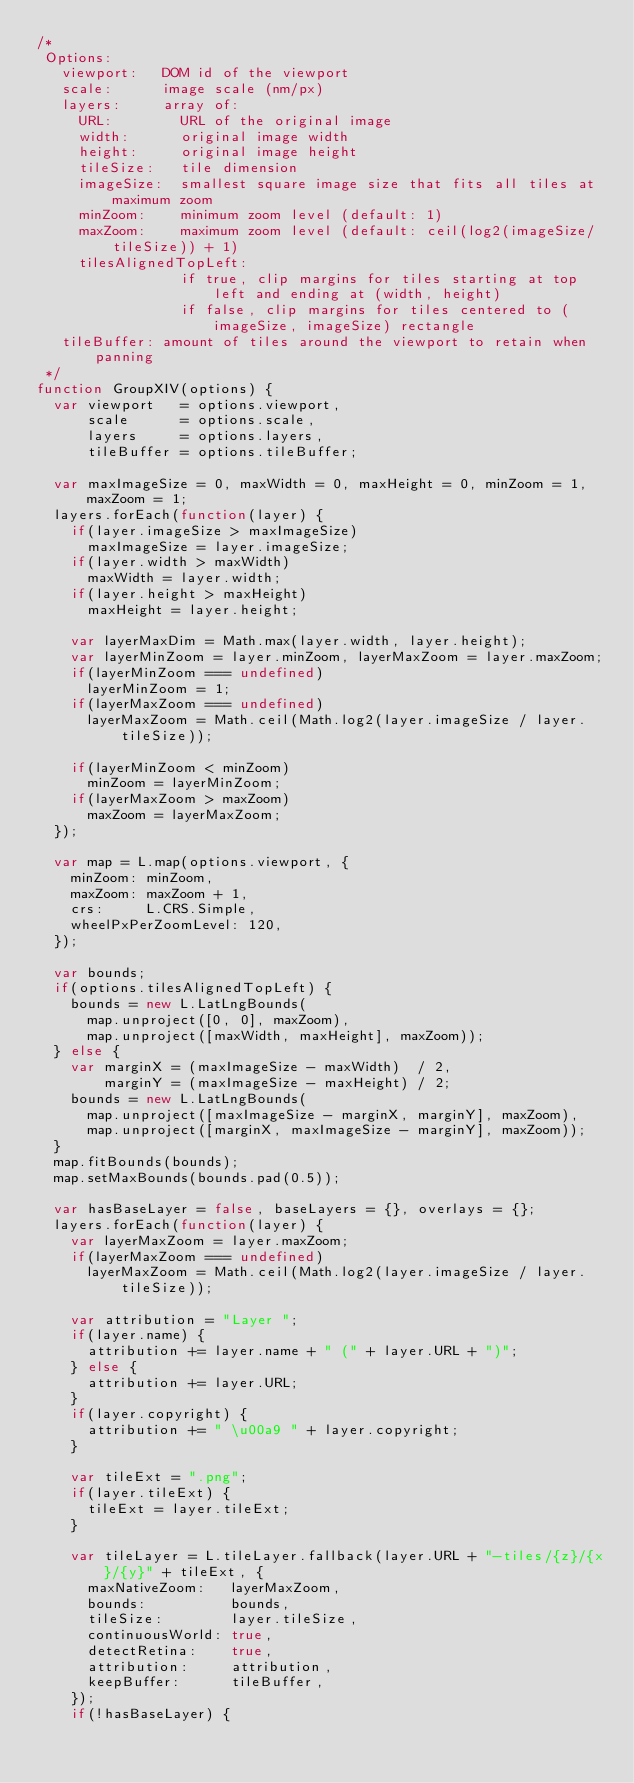Convert code to text. <code><loc_0><loc_0><loc_500><loc_500><_JavaScript_>/*
 Options:
   viewport:   DOM id of the viewport
   scale:      image scale (nm/px)
   layers:     array of:
     URL:        URL of the original image
     width:      original image width
     height:     original image height
     tileSize:   tile dimension
     imageSize:  smallest square image size that fits all tiles at maximum zoom
     minZoom:    minimum zoom level (default: 1)
     maxZoom:    maximum zoom level (default: ceil(log2(imageSize/tileSize)) + 1)
     tilesAlignedTopLeft:
                 if true, clip margins for tiles starting at top left and ending at (width, height)
                 if false, clip margins for tiles centered to (imageSize, imageSize) rectangle
   tileBuffer: amount of tiles around the viewport to retain when panning
 */
function GroupXIV(options) {
  var viewport   = options.viewport,
      scale      = options.scale,
      layers     = options.layers,
      tileBuffer = options.tileBuffer;

  var maxImageSize = 0, maxWidth = 0, maxHeight = 0, minZoom = 1, maxZoom = 1;
  layers.forEach(function(layer) {
    if(layer.imageSize > maxImageSize)
      maxImageSize = layer.imageSize;
    if(layer.width > maxWidth)
      maxWidth = layer.width;
    if(layer.height > maxHeight)
      maxHeight = layer.height;

    var layerMaxDim = Math.max(layer.width, layer.height);
    var layerMinZoom = layer.minZoom, layerMaxZoom = layer.maxZoom;
    if(layerMinZoom === undefined)
      layerMinZoom = 1;
    if(layerMaxZoom === undefined)
      layerMaxZoom = Math.ceil(Math.log2(layer.imageSize / layer.tileSize));

    if(layerMinZoom < minZoom)
      minZoom = layerMinZoom;
    if(layerMaxZoom > maxZoom)
      maxZoom = layerMaxZoom;
  });

  var map = L.map(options.viewport, {
    minZoom: minZoom,
    maxZoom: maxZoom + 1,
    crs:     L.CRS.Simple,
    wheelPxPerZoomLevel: 120,
  });

  var bounds;
  if(options.tilesAlignedTopLeft) {
    bounds = new L.LatLngBounds(
      map.unproject([0, 0], maxZoom),
      map.unproject([maxWidth, maxHeight], maxZoom));
  } else {
    var marginX = (maxImageSize - maxWidth)  / 2,
        marginY = (maxImageSize - maxHeight) / 2;
    bounds = new L.LatLngBounds(
      map.unproject([maxImageSize - marginX, marginY], maxZoom),
      map.unproject([marginX, maxImageSize - marginY], maxZoom));
  }
  map.fitBounds(bounds);
  map.setMaxBounds(bounds.pad(0.5));

  var hasBaseLayer = false, baseLayers = {}, overlays = {};
  layers.forEach(function(layer) {
    var layerMaxZoom = layer.maxZoom;
    if(layerMaxZoom === undefined)
      layerMaxZoom = Math.ceil(Math.log2(layer.imageSize / layer.tileSize));

    var attribution = "Layer ";
    if(layer.name) {
      attribution += layer.name + " (" + layer.URL + ")";
    } else {
      attribution += layer.URL;
    }
    if(layer.copyright) {
      attribution += " \u00a9 " + layer.copyright;
    }

    var tileExt = ".png";
    if(layer.tileExt) {
      tileExt = layer.tileExt;
    }

    var tileLayer = L.tileLayer.fallback(layer.URL + "-tiles/{z}/{x}/{y}" + tileExt, {
      maxNativeZoom:   layerMaxZoom,
      bounds:          bounds,
      tileSize:        layer.tileSize,
      continuousWorld: true,
      detectRetina:    true,
      attribution:     attribution,
      keepBuffer:      tileBuffer,
    });
    if(!hasBaseLayer) {</code> 